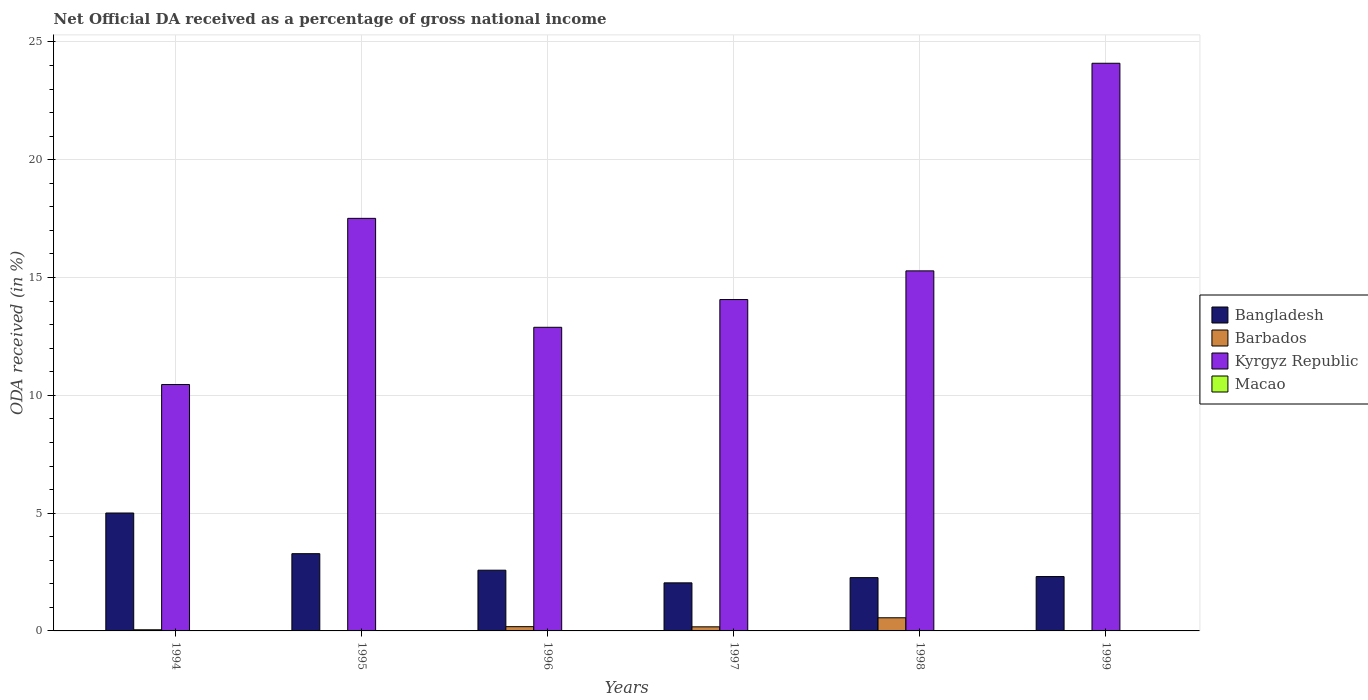How many different coloured bars are there?
Ensure brevity in your answer.  4. Are the number of bars on each tick of the X-axis equal?
Your answer should be compact. No. How many bars are there on the 2nd tick from the right?
Give a very brief answer. 4. In how many cases, is the number of bars for a given year not equal to the number of legend labels?
Make the answer very short. 2. What is the net official DA received in Bangladesh in 1994?
Provide a short and direct response. 5. Across all years, what is the maximum net official DA received in Macao?
Make the answer very short. 0.01. Across all years, what is the minimum net official DA received in Macao?
Offer a terse response. 0. In which year was the net official DA received in Kyrgyz Republic maximum?
Your answer should be compact. 1999. What is the total net official DA received in Kyrgyz Republic in the graph?
Ensure brevity in your answer.  94.3. What is the difference between the net official DA received in Kyrgyz Republic in 1994 and that in 1996?
Your answer should be compact. -2.43. What is the difference between the net official DA received in Bangladesh in 1997 and the net official DA received in Macao in 1996?
Ensure brevity in your answer.  2.04. What is the average net official DA received in Kyrgyz Republic per year?
Your answer should be very brief. 15.72. In the year 1994, what is the difference between the net official DA received in Barbados and net official DA received in Bangladesh?
Ensure brevity in your answer.  -4.96. In how many years, is the net official DA received in Bangladesh greater than 5 %?
Ensure brevity in your answer.  1. What is the ratio of the net official DA received in Macao in 1996 to that in 1997?
Make the answer very short. 0.9. What is the difference between the highest and the second highest net official DA received in Kyrgyz Republic?
Offer a terse response. 6.58. What is the difference between the highest and the lowest net official DA received in Bangladesh?
Ensure brevity in your answer.  2.96. In how many years, is the net official DA received in Kyrgyz Republic greater than the average net official DA received in Kyrgyz Republic taken over all years?
Your answer should be compact. 2. Are all the bars in the graph horizontal?
Give a very brief answer. No. How many years are there in the graph?
Your answer should be compact. 6. Does the graph contain grids?
Give a very brief answer. Yes. How many legend labels are there?
Give a very brief answer. 4. How are the legend labels stacked?
Offer a very short reply. Vertical. What is the title of the graph?
Offer a very short reply. Net Official DA received as a percentage of gross national income. Does "Germany" appear as one of the legend labels in the graph?
Ensure brevity in your answer.  No. What is the label or title of the Y-axis?
Offer a terse response. ODA received (in %). What is the ODA received (in %) of Bangladesh in 1994?
Offer a very short reply. 5. What is the ODA received (in %) in Barbados in 1994?
Your answer should be compact. 0.05. What is the ODA received (in %) of Kyrgyz Republic in 1994?
Offer a terse response. 10.46. What is the ODA received (in %) of Macao in 1994?
Ensure brevity in your answer.  0. What is the ODA received (in %) of Bangladesh in 1995?
Your answer should be very brief. 3.28. What is the ODA received (in %) of Kyrgyz Republic in 1995?
Your answer should be very brief. 17.51. What is the ODA received (in %) in Macao in 1995?
Give a very brief answer. 0. What is the ODA received (in %) of Bangladesh in 1996?
Ensure brevity in your answer.  2.58. What is the ODA received (in %) in Barbados in 1996?
Give a very brief answer. 0.18. What is the ODA received (in %) of Kyrgyz Republic in 1996?
Provide a short and direct response. 12.89. What is the ODA received (in %) in Macao in 1996?
Provide a succinct answer. 0. What is the ODA received (in %) in Bangladesh in 1997?
Provide a succinct answer. 2.04. What is the ODA received (in %) in Barbados in 1997?
Offer a very short reply. 0.17. What is the ODA received (in %) in Kyrgyz Republic in 1997?
Provide a succinct answer. 14.06. What is the ODA received (in %) in Macao in 1997?
Keep it short and to the point. 0.01. What is the ODA received (in %) in Bangladesh in 1998?
Make the answer very short. 2.26. What is the ODA received (in %) in Barbados in 1998?
Provide a succinct answer. 0.56. What is the ODA received (in %) in Kyrgyz Republic in 1998?
Offer a very short reply. 15.28. What is the ODA received (in %) in Macao in 1998?
Your answer should be compact. 0.01. What is the ODA received (in %) of Bangladesh in 1999?
Make the answer very short. 2.31. What is the ODA received (in %) of Barbados in 1999?
Give a very brief answer. 0. What is the ODA received (in %) of Kyrgyz Republic in 1999?
Provide a succinct answer. 24.09. What is the ODA received (in %) in Macao in 1999?
Offer a terse response. 0.01. Across all years, what is the maximum ODA received (in %) of Bangladesh?
Give a very brief answer. 5. Across all years, what is the maximum ODA received (in %) in Barbados?
Offer a very short reply. 0.56. Across all years, what is the maximum ODA received (in %) of Kyrgyz Republic?
Provide a succinct answer. 24.09. Across all years, what is the maximum ODA received (in %) of Macao?
Make the answer very short. 0.01. Across all years, what is the minimum ODA received (in %) in Bangladesh?
Ensure brevity in your answer.  2.04. Across all years, what is the minimum ODA received (in %) of Barbados?
Offer a very short reply. 0. Across all years, what is the minimum ODA received (in %) of Kyrgyz Republic?
Your answer should be very brief. 10.46. What is the total ODA received (in %) in Bangladesh in the graph?
Your response must be concise. 17.47. What is the total ODA received (in %) of Barbados in the graph?
Your answer should be very brief. 0.96. What is the total ODA received (in %) of Kyrgyz Republic in the graph?
Your answer should be very brief. 94.3. What is the total ODA received (in %) of Macao in the graph?
Your answer should be very brief. 0.03. What is the difference between the ODA received (in %) of Bangladesh in 1994 and that in 1995?
Provide a short and direct response. 1.73. What is the difference between the ODA received (in %) of Kyrgyz Republic in 1994 and that in 1995?
Offer a terse response. -7.05. What is the difference between the ODA received (in %) of Bangladesh in 1994 and that in 1996?
Your response must be concise. 2.43. What is the difference between the ODA received (in %) in Barbados in 1994 and that in 1996?
Provide a short and direct response. -0.13. What is the difference between the ODA received (in %) in Kyrgyz Republic in 1994 and that in 1996?
Provide a short and direct response. -2.43. What is the difference between the ODA received (in %) of Macao in 1994 and that in 1996?
Your answer should be compact. -0. What is the difference between the ODA received (in %) of Bangladesh in 1994 and that in 1997?
Offer a terse response. 2.96. What is the difference between the ODA received (in %) of Barbados in 1994 and that in 1997?
Keep it short and to the point. -0.13. What is the difference between the ODA received (in %) of Kyrgyz Republic in 1994 and that in 1997?
Your answer should be compact. -3.61. What is the difference between the ODA received (in %) in Macao in 1994 and that in 1997?
Offer a terse response. -0. What is the difference between the ODA received (in %) in Bangladesh in 1994 and that in 1998?
Your answer should be very brief. 2.74. What is the difference between the ODA received (in %) in Barbados in 1994 and that in 1998?
Offer a very short reply. -0.51. What is the difference between the ODA received (in %) in Kyrgyz Republic in 1994 and that in 1998?
Offer a very short reply. -4.82. What is the difference between the ODA received (in %) in Macao in 1994 and that in 1998?
Provide a short and direct response. -0. What is the difference between the ODA received (in %) of Bangladesh in 1994 and that in 1999?
Offer a terse response. 2.7. What is the difference between the ODA received (in %) in Kyrgyz Republic in 1994 and that in 1999?
Your answer should be very brief. -13.64. What is the difference between the ODA received (in %) in Macao in 1994 and that in 1999?
Your answer should be very brief. -0. What is the difference between the ODA received (in %) of Bangladesh in 1995 and that in 1996?
Keep it short and to the point. 0.7. What is the difference between the ODA received (in %) of Kyrgyz Republic in 1995 and that in 1996?
Give a very brief answer. 4.62. What is the difference between the ODA received (in %) of Bangladesh in 1995 and that in 1997?
Offer a terse response. 1.24. What is the difference between the ODA received (in %) of Kyrgyz Republic in 1995 and that in 1997?
Give a very brief answer. 3.45. What is the difference between the ODA received (in %) of Bangladesh in 1995 and that in 1998?
Your answer should be very brief. 1.02. What is the difference between the ODA received (in %) in Kyrgyz Republic in 1995 and that in 1998?
Provide a short and direct response. 2.23. What is the difference between the ODA received (in %) in Bangladesh in 1995 and that in 1999?
Keep it short and to the point. 0.97. What is the difference between the ODA received (in %) of Kyrgyz Republic in 1995 and that in 1999?
Offer a terse response. -6.58. What is the difference between the ODA received (in %) in Bangladesh in 1996 and that in 1997?
Make the answer very short. 0.54. What is the difference between the ODA received (in %) in Barbados in 1996 and that in 1997?
Keep it short and to the point. 0.01. What is the difference between the ODA received (in %) of Kyrgyz Republic in 1996 and that in 1997?
Your answer should be compact. -1.18. What is the difference between the ODA received (in %) of Macao in 1996 and that in 1997?
Your response must be concise. -0. What is the difference between the ODA received (in %) of Bangladesh in 1996 and that in 1998?
Make the answer very short. 0.32. What is the difference between the ODA received (in %) of Barbados in 1996 and that in 1998?
Your answer should be compact. -0.38. What is the difference between the ODA received (in %) of Kyrgyz Republic in 1996 and that in 1998?
Offer a terse response. -2.4. What is the difference between the ODA received (in %) in Macao in 1996 and that in 1998?
Make the answer very short. -0. What is the difference between the ODA received (in %) in Bangladesh in 1996 and that in 1999?
Provide a short and direct response. 0.27. What is the difference between the ODA received (in %) of Kyrgyz Republic in 1996 and that in 1999?
Provide a short and direct response. -11.21. What is the difference between the ODA received (in %) in Macao in 1996 and that in 1999?
Make the answer very short. -0. What is the difference between the ODA received (in %) in Bangladesh in 1997 and that in 1998?
Provide a succinct answer. -0.22. What is the difference between the ODA received (in %) in Barbados in 1997 and that in 1998?
Provide a short and direct response. -0.38. What is the difference between the ODA received (in %) of Kyrgyz Republic in 1997 and that in 1998?
Keep it short and to the point. -1.22. What is the difference between the ODA received (in %) of Macao in 1997 and that in 1998?
Ensure brevity in your answer.  -0. What is the difference between the ODA received (in %) of Bangladesh in 1997 and that in 1999?
Make the answer very short. -0.27. What is the difference between the ODA received (in %) of Kyrgyz Republic in 1997 and that in 1999?
Keep it short and to the point. -10.03. What is the difference between the ODA received (in %) of Macao in 1997 and that in 1999?
Offer a terse response. -0. What is the difference between the ODA received (in %) of Bangladesh in 1998 and that in 1999?
Offer a very short reply. -0.05. What is the difference between the ODA received (in %) in Kyrgyz Republic in 1998 and that in 1999?
Give a very brief answer. -8.81. What is the difference between the ODA received (in %) in Macao in 1998 and that in 1999?
Offer a terse response. 0. What is the difference between the ODA received (in %) of Bangladesh in 1994 and the ODA received (in %) of Kyrgyz Republic in 1995?
Keep it short and to the point. -12.51. What is the difference between the ODA received (in %) of Barbados in 1994 and the ODA received (in %) of Kyrgyz Republic in 1995?
Offer a very short reply. -17.46. What is the difference between the ODA received (in %) of Bangladesh in 1994 and the ODA received (in %) of Barbados in 1996?
Keep it short and to the point. 4.82. What is the difference between the ODA received (in %) in Bangladesh in 1994 and the ODA received (in %) in Kyrgyz Republic in 1996?
Offer a terse response. -7.88. What is the difference between the ODA received (in %) of Bangladesh in 1994 and the ODA received (in %) of Macao in 1996?
Your response must be concise. 5. What is the difference between the ODA received (in %) in Barbados in 1994 and the ODA received (in %) in Kyrgyz Republic in 1996?
Make the answer very short. -12.84. What is the difference between the ODA received (in %) of Barbados in 1994 and the ODA received (in %) of Macao in 1996?
Your answer should be compact. 0.04. What is the difference between the ODA received (in %) in Kyrgyz Republic in 1994 and the ODA received (in %) in Macao in 1996?
Your response must be concise. 10.45. What is the difference between the ODA received (in %) of Bangladesh in 1994 and the ODA received (in %) of Barbados in 1997?
Offer a very short reply. 4.83. What is the difference between the ODA received (in %) of Bangladesh in 1994 and the ODA received (in %) of Kyrgyz Republic in 1997?
Provide a succinct answer. -9.06. What is the difference between the ODA received (in %) in Bangladesh in 1994 and the ODA received (in %) in Macao in 1997?
Provide a short and direct response. 5. What is the difference between the ODA received (in %) of Barbados in 1994 and the ODA received (in %) of Kyrgyz Republic in 1997?
Provide a succinct answer. -14.02. What is the difference between the ODA received (in %) in Barbados in 1994 and the ODA received (in %) in Macao in 1997?
Your response must be concise. 0.04. What is the difference between the ODA received (in %) of Kyrgyz Republic in 1994 and the ODA received (in %) of Macao in 1997?
Offer a very short reply. 10.45. What is the difference between the ODA received (in %) in Bangladesh in 1994 and the ODA received (in %) in Barbados in 1998?
Offer a very short reply. 4.45. What is the difference between the ODA received (in %) in Bangladesh in 1994 and the ODA received (in %) in Kyrgyz Republic in 1998?
Offer a very short reply. -10.28. What is the difference between the ODA received (in %) of Bangladesh in 1994 and the ODA received (in %) of Macao in 1998?
Offer a very short reply. 5. What is the difference between the ODA received (in %) of Barbados in 1994 and the ODA received (in %) of Kyrgyz Republic in 1998?
Ensure brevity in your answer.  -15.23. What is the difference between the ODA received (in %) in Barbados in 1994 and the ODA received (in %) in Macao in 1998?
Your response must be concise. 0.04. What is the difference between the ODA received (in %) of Kyrgyz Republic in 1994 and the ODA received (in %) of Macao in 1998?
Make the answer very short. 10.45. What is the difference between the ODA received (in %) in Bangladesh in 1994 and the ODA received (in %) in Kyrgyz Republic in 1999?
Give a very brief answer. -19.09. What is the difference between the ODA received (in %) of Bangladesh in 1994 and the ODA received (in %) of Macao in 1999?
Your answer should be very brief. 5. What is the difference between the ODA received (in %) in Barbados in 1994 and the ODA received (in %) in Kyrgyz Republic in 1999?
Offer a terse response. -24.05. What is the difference between the ODA received (in %) of Barbados in 1994 and the ODA received (in %) of Macao in 1999?
Provide a short and direct response. 0.04. What is the difference between the ODA received (in %) in Kyrgyz Republic in 1994 and the ODA received (in %) in Macao in 1999?
Provide a short and direct response. 10.45. What is the difference between the ODA received (in %) of Bangladesh in 1995 and the ODA received (in %) of Barbados in 1996?
Provide a succinct answer. 3.1. What is the difference between the ODA received (in %) in Bangladesh in 1995 and the ODA received (in %) in Kyrgyz Republic in 1996?
Give a very brief answer. -9.61. What is the difference between the ODA received (in %) in Bangladesh in 1995 and the ODA received (in %) in Macao in 1996?
Your answer should be compact. 3.27. What is the difference between the ODA received (in %) in Kyrgyz Republic in 1995 and the ODA received (in %) in Macao in 1996?
Ensure brevity in your answer.  17.51. What is the difference between the ODA received (in %) of Bangladesh in 1995 and the ODA received (in %) of Barbados in 1997?
Your response must be concise. 3.1. What is the difference between the ODA received (in %) in Bangladesh in 1995 and the ODA received (in %) in Kyrgyz Republic in 1997?
Ensure brevity in your answer.  -10.79. What is the difference between the ODA received (in %) in Bangladesh in 1995 and the ODA received (in %) in Macao in 1997?
Offer a very short reply. 3.27. What is the difference between the ODA received (in %) of Kyrgyz Republic in 1995 and the ODA received (in %) of Macao in 1997?
Provide a short and direct response. 17.51. What is the difference between the ODA received (in %) of Bangladesh in 1995 and the ODA received (in %) of Barbados in 1998?
Ensure brevity in your answer.  2.72. What is the difference between the ODA received (in %) in Bangladesh in 1995 and the ODA received (in %) in Kyrgyz Republic in 1998?
Keep it short and to the point. -12. What is the difference between the ODA received (in %) in Bangladesh in 1995 and the ODA received (in %) in Macao in 1998?
Make the answer very short. 3.27. What is the difference between the ODA received (in %) in Kyrgyz Republic in 1995 and the ODA received (in %) in Macao in 1998?
Give a very brief answer. 17.5. What is the difference between the ODA received (in %) in Bangladesh in 1995 and the ODA received (in %) in Kyrgyz Republic in 1999?
Offer a terse response. -20.82. What is the difference between the ODA received (in %) in Bangladesh in 1995 and the ODA received (in %) in Macao in 1999?
Provide a succinct answer. 3.27. What is the difference between the ODA received (in %) of Kyrgyz Republic in 1995 and the ODA received (in %) of Macao in 1999?
Your answer should be very brief. 17.51. What is the difference between the ODA received (in %) of Bangladesh in 1996 and the ODA received (in %) of Barbados in 1997?
Provide a short and direct response. 2.4. What is the difference between the ODA received (in %) of Bangladesh in 1996 and the ODA received (in %) of Kyrgyz Republic in 1997?
Your answer should be very brief. -11.49. What is the difference between the ODA received (in %) of Bangladesh in 1996 and the ODA received (in %) of Macao in 1997?
Your response must be concise. 2.57. What is the difference between the ODA received (in %) in Barbados in 1996 and the ODA received (in %) in Kyrgyz Republic in 1997?
Keep it short and to the point. -13.88. What is the difference between the ODA received (in %) of Barbados in 1996 and the ODA received (in %) of Macao in 1997?
Offer a terse response. 0.18. What is the difference between the ODA received (in %) in Kyrgyz Republic in 1996 and the ODA received (in %) in Macao in 1997?
Your response must be concise. 12.88. What is the difference between the ODA received (in %) in Bangladesh in 1996 and the ODA received (in %) in Barbados in 1998?
Your answer should be very brief. 2.02. What is the difference between the ODA received (in %) of Bangladesh in 1996 and the ODA received (in %) of Kyrgyz Republic in 1998?
Provide a short and direct response. -12.71. What is the difference between the ODA received (in %) of Bangladesh in 1996 and the ODA received (in %) of Macao in 1998?
Your answer should be very brief. 2.57. What is the difference between the ODA received (in %) in Barbados in 1996 and the ODA received (in %) in Kyrgyz Republic in 1998?
Your answer should be compact. -15.1. What is the difference between the ODA received (in %) in Barbados in 1996 and the ODA received (in %) in Macao in 1998?
Give a very brief answer. 0.17. What is the difference between the ODA received (in %) in Kyrgyz Republic in 1996 and the ODA received (in %) in Macao in 1998?
Your answer should be very brief. 12.88. What is the difference between the ODA received (in %) of Bangladesh in 1996 and the ODA received (in %) of Kyrgyz Republic in 1999?
Your answer should be very brief. -21.52. What is the difference between the ODA received (in %) in Bangladesh in 1996 and the ODA received (in %) in Macao in 1999?
Your answer should be compact. 2.57. What is the difference between the ODA received (in %) in Barbados in 1996 and the ODA received (in %) in Kyrgyz Republic in 1999?
Offer a terse response. -23.91. What is the difference between the ODA received (in %) of Barbados in 1996 and the ODA received (in %) of Macao in 1999?
Make the answer very short. 0.18. What is the difference between the ODA received (in %) in Kyrgyz Republic in 1996 and the ODA received (in %) in Macao in 1999?
Provide a short and direct response. 12.88. What is the difference between the ODA received (in %) of Bangladesh in 1997 and the ODA received (in %) of Barbados in 1998?
Give a very brief answer. 1.48. What is the difference between the ODA received (in %) in Bangladesh in 1997 and the ODA received (in %) in Kyrgyz Republic in 1998?
Offer a terse response. -13.24. What is the difference between the ODA received (in %) in Bangladesh in 1997 and the ODA received (in %) in Macao in 1998?
Give a very brief answer. 2.03. What is the difference between the ODA received (in %) in Barbados in 1997 and the ODA received (in %) in Kyrgyz Republic in 1998?
Provide a succinct answer. -15.11. What is the difference between the ODA received (in %) of Barbados in 1997 and the ODA received (in %) of Macao in 1998?
Make the answer very short. 0.17. What is the difference between the ODA received (in %) of Kyrgyz Republic in 1997 and the ODA received (in %) of Macao in 1998?
Offer a very short reply. 14.06. What is the difference between the ODA received (in %) of Bangladesh in 1997 and the ODA received (in %) of Kyrgyz Republic in 1999?
Make the answer very short. -22.05. What is the difference between the ODA received (in %) of Bangladesh in 1997 and the ODA received (in %) of Macao in 1999?
Your answer should be very brief. 2.04. What is the difference between the ODA received (in %) of Barbados in 1997 and the ODA received (in %) of Kyrgyz Republic in 1999?
Ensure brevity in your answer.  -23.92. What is the difference between the ODA received (in %) of Barbados in 1997 and the ODA received (in %) of Macao in 1999?
Provide a succinct answer. 0.17. What is the difference between the ODA received (in %) in Kyrgyz Republic in 1997 and the ODA received (in %) in Macao in 1999?
Your answer should be compact. 14.06. What is the difference between the ODA received (in %) of Bangladesh in 1998 and the ODA received (in %) of Kyrgyz Republic in 1999?
Offer a very short reply. -21.83. What is the difference between the ODA received (in %) of Bangladesh in 1998 and the ODA received (in %) of Macao in 1999?
Your answer should be very brief. 2.26. What is the difference between the ODA received (in %) in Barbados in 1998 and the ODA received (in %) in Kyrgyz Republic in 1999?
Your response must be concise. -23.54. What is the difference between the ODA received (in %) in Barbados in 1998 and the ODA received (in %) in Macao in 1999?
Ensure brevity in your answer.  0.55. What is the difference between the ODA received (in %) of Kyrgyz Republic in 1998 and the ODA received (in %) of Macao in 1999?
Ensure brevity in your answer.  15.28. What is the average ODA received (in %) in Bangladesh per year?
Your answer should be compact. 2.91. What is the average ODA received (in %) in Barbados per year?
Your answer should be very brief. 0.16. What is the average ODA received (in %) of Kyrgyz Republic per year?
Make the answer very short. 15.72. What is the average ODA received (in %) of Macao per year?
Provide a succinct answer. 0. In the year 1994, what is the difference between the ODA received (in %) of Bangladesh and ODA received (in %) of Barbados?
Your response must be concise. 4.96. In the year 1994, what is the difference between the ODA received (in %) in Bangladesh and ODA received (in %) in Kyrgyz Republic?
Your answer should be very brief. -5.45. In the year 1994, what is the difference between the ODA received (in %) in Bangladesh and ODA received (in %) in Macao?
Provide a short and direct response. 5. In the year 1994, what is the difference between the ODA received (in %) of Barbados and ODA received (in %) of Kyrgyz Republic?
Offer a terse response. -10.41. In the year 1994, what is the difference between the ODA received (in %) in Barbados and ODA received (in %) in Macao?
Make the answer very short. 0.04. In the year 1994, what is the difference between the ODA received (in %) of Kyrgyz Republic and ODA received (in %) of Macao?
Give a very brief answer. 10.45. In the year 1995, what is the difference between the ODA received (in %) of Bangladesh and ODA received (in %) of Kyrgyz Republic?
Your answer should be compact. -14.23. In the year 1996, what is the difference between the ODA received (in %) of Bangladesh and ODA received (in %) of Barbados?
Make the answer very short. 2.4. In the year 1996, what is the difference between the ODA received (in %) of Bangladesh and ODA received (in %) of Kyrgyz Republic?
Your answer should be very brief. -10.31. In the year 1996, what is the difference between the ODA received (in %) in Bangladesh and ODA received (in %) in Macao?
Make the answer very short. 2.57. In the year 1996, what is the difference between the ODA received (in %) of Barbados and ODA received (in %) of Kyrgyz Republic?
Your answer should be compact. -12.71. In the year 1996, what is the difference between the ODA received (in %) in Barbados and ODA received (in %) in Macao?
Your answer should be very brief. 0.18. In the year 1996, what is the difference between the ODA received (in %) in Kyrgyz Republic and ODA received (in %) in Macao?
Your answer should be compact. 12.88. In the year 1997, what is the difference between the ODA received (in %) of Bangladesh and ODA received (in %) of Barbados?
Ensure brevity in your answer.  1.87. In the year 1997, what is the difference between the ODA received (in %) of Bangladesh and ODA received (in %) of Kyrgyz Republic?
Keep it short and to the point. -12.02. In the year 1997, what is the difference between the ODA received (in %) of Bangladesh and ODA received (in %) of Macao?
Your response must be concise. 2.04. In the year 1997, what is the difference between the ODA received (in %) of Barbados and ODA received (in %) of Kyrgyz Republic?
Provide a short and direct response. -13.89. In the year 1997, what is the difference between the ODA received (in %) in Barbados and ODA received (in %) in Macao?
Keep it short and to the point. 0.17. In the year 1997, what is the difference between the ODA received (in %) in Kyrgyz Republic and ODA received (in %) in Macao?
Your response must be concise. 14.06. In the year 1998, what is the difference between the ODA received (in %) of Bangladesh and ODA received (in %) of Barbados?
Make the answer very short. 1.7. In the year 1998, what is the difference between the ODA received (in %) in Bangladesh and ODA received (in %) in Kyrgyz Republic?
Offer a terse response. -13.02. In the year 1998, what is the difference between the ODA received (in %) of Bangladesh and ODA received (in %) of Macao?
Ensure brevity in your answer.  2.25. In the year 1998, what is the difference between the ODA received (in %) in Barbados and ODA received (in %) in Kyrgyz Republic?
Your answer should be very brief. -14.72. In the year 1998, what is the difference between the ODA received (in %) of Barbados and ODA received (in %) of Macao?
Offer a terse response. 0.55. In the year 1998, what is the difference between the ODA received (in %) of Kyrgyz Republic and ODA received (in %) of Macao?
Provide a succinct answer. 15.27. In the year 1999, what is the difference between the ODA received (in %) in Bangladesh and ODA received (in %) in Kyrgyz Republic?
Keep it short and to the point. -21.79. In the year 1999, what is the difference between the ODA received (in %) in Bangladesh and ODA received (in %) in Macao?
Your answer should be very brief. 2.3. In the year 1999, what is the difference between the ODA received (in %) of Kyrgyz Republic and ODA received (in %) of Macao?
Provide a succinct answer. 24.09. What is the ratio of the ODA received (in %) in Bangladesh in 1994 to that in 1995?
Your answer should be compact. 1.53. What is the ratio of the ODA received (in %) of Kyrgyz Republic in 1994 to that in 1995?
Provide a short and direct response. 0.6. What is the ratio of the ODA received (in %) of Bangladesh in 1994 to that in 1996?
Provide a short and direct response. 1.94. What is the ratio of the ODA received (in %) in Barbados in 1994 to that in 1996?
Provide a succinct answer. 0.27. What is the ratio of the ODA received (in %) in Kyrgyz Republic in 1994 to that in 1996?
Provide a short and direct response. 0.81. What is the ratio of the ODA received (in %) of Bangladesh in 1994 to that in 1997?
Keep it short and to the point. 2.45. What is the ratio of the ODA received (in %) of Barbados in 1994 to that in 1997?
Provide a short and direct response. 0.28. What is the ratio of the ODA received (in %) of Kyrgyz Republic in 1994 to that in 1997?
Offer a terse response. 0.74. What is the ratio of the ODA received (in %) in Macao in 1994 to that in 1997?
Your answer should be compact. 0.9. What is the ratio of the ODA received (in %) in Bangladesh in 1994 to that in 1998?
Your answer should be compact. 2.21. What is the ratio of the ODA received (in %) in Barbados in 1994 to that in 1998?
Offer a terse response. 0.09. What is the ratio of the ODA received (in %) of Kyrgyz Republic in 1994 to that in 1998?
Offer a terse response. 0.68. What is the ratio of the ODA received (in %) of Macao in 1994 to that in 1998?
Make the answer very short. 0.6. What is the ratio of the ODA received (in %) in Bangladesh in 1994 to that in 1999?
Give a very brief answer. 2.17. What is the ratio of the ODA received (in %) in Kyrgyz Republic in 1994 to that in 1999?
Provide a succinct answer. 0.43. What is the ratio of the ODA received (in %) of Macao in 1994 to that in 1999?
Keep it short and to the point. 0.88. What is the ratio of the ODA received (in %) of Bangladesh in 1995 to that in 1996?
Offer a terse response. 1.27. What is the ratio of the ODA received (in %) in Kyrgyz Republic in 1995 to that in 1996?
Make the answer very short. 1.36. What is the ratio of the ODA received (in %) in Bangladesh in 1995 to that in 1997?
Provide a succinct answer. 1.61. What is the ratio of the ODA received (in %) of Kyrgyz Republic in 1995 to that in 1997?
Provide a succinct answer. 1.25. What is the ratio of the ODA received (in %) of Bangladesh in 1995 to that in 1998?
Provide a short and direct response. 1.45. What is the ratio of the ODA received (in %) of Kyrgyz Republic in 1995 to that in 1998?
Ensure brevity in your answer.  1.15. What is the ratio of the ODA received (in %) of Bangladesh in 1995 to that in 1999?
Ensure brevity in your answer.  1.42. What is the ratio of the ODA received (in %) of Kyrgyz Republic in 1995 to that in 1999?
Offer a terse response. 0.73. What is the ratio of the ODA received (in %) of Bangladesh in 1996 to that in 1997?
Make the answer very short. 1.26. What is the ratio of the ODA received (in %) of Barbados in 1996 to that in 1997?
Your answer should be compact. 1.04. What is the ratio of the ODA received (in %) in Kyrgyz Republic in 1996 to that in 1997?
Your answer should be very brief. 0.92. What is the ratio of the ODA received (in %) in Macao in 1996 to that in 1997?
Offer a terse response. 0.9. What is the ratio of the ODA received (in %) in Bangladesh in 1996 to that in 1998?
Offer a terse response. 1.14. What is the ratio of the ODA received (in %) of Barbados in 1996 to that in 1998?
Keep it short and to the point. 0.32. What is the ratio of the ODA received (in %) in Kyrgyz Republic in 1996 to that in 1998?
Ensure brevity in your answer.  0.84. What is the ratio of the ODA received (in %) in Macao in 1996 to that in 1998?
Provide a short and direct response. 0.6. What is the ratio of the ODA received (in %) of Bangladesh in 1996 to that in 1999?
Ensure brevity in your answer.  1.12. What is the ratio of the ODA received (in %) in Kyrgyz Republic in 1996 to that in 1999?
Your answer should be compact. 0.53. What is the ratio of the ODA received (in %) in Macao in 1996 to that in 1999?
Provide a succinct answer. 0.88. What is the ratio of the ODA received (in %) in Bangladesh in 1997 to that in 1998?
Your answer should be compact. 0.9. What is the ratio of the ODA received (in %) in Barbados in 1997 to that in 1998?
Provide a succinct answer. 0.31. What is the ratio of the ODA received (in %) of Kyrgyz Republic in 1997 to that in 1998?
Your answer should be compact. 0.92. What is the ratio of the ODA received (in %) of Macao in 1997 to that in 1998?
Offer a terse response. 0.67. What is the ratio of the ODA received (in %) of Bangladesh in 1997 to that in 1999?
Make the answer very short. 0.88. What is the ratio of the ODA received (in %) in Kyrgyz Republic in 1997 to that in 1999?
Your answer should be very brief. 0.58. What is the ratio of the ODA received (in %) in Macao in 1997 to that in 1999?
Offer a very short reply. 0.98. What is the ratio of the ODA received (in %) of Bangladesh in 1998 to that in 1999?
Your answer should be very brief. 0.98. What is the ratio of the ODA received (in %) in Kyrgyz Republic in 1998 to that in 1999?
Ensure brevity in your answer.  0.63. What is the ratio of the ODA received (in %) in Macao in 1998 to that in 1999?
Offer a very short reply. 1.47. What is the difference between the highest and the second highest ODA received (in %) of Bangladesh?
Your answer should be compact. 1.73. What is the difference between the highest and the second highest ODA received (in %) of Barbados?
Your answer should be very brief. 0.38. What is the difference between the highest and the second highest ODA received (in %) in Kyrgyz Republic?
Give a very brief answer. 6.58. What is the difference between the highest and the second highest ODA received (in %) in Macao?
Provide a short and direct response. 0. What is the difference between the highest and the lowest ODA received (in %) in Bangladesh?
Ensure brevity in your answer.  2.96. What is the difference between the highest and the lowest ODA received (in %) in Barbados?
Your answer should be very brief. 0.56. What is the difference between the highest and the lowest ODA received (in %) of Kyrgyz Republic?
Your answer should be very brief. 13.64. What is the difference between the highest and the lowest ODA received (in %) of Macao?
Give a very brief answer. 0.01. 